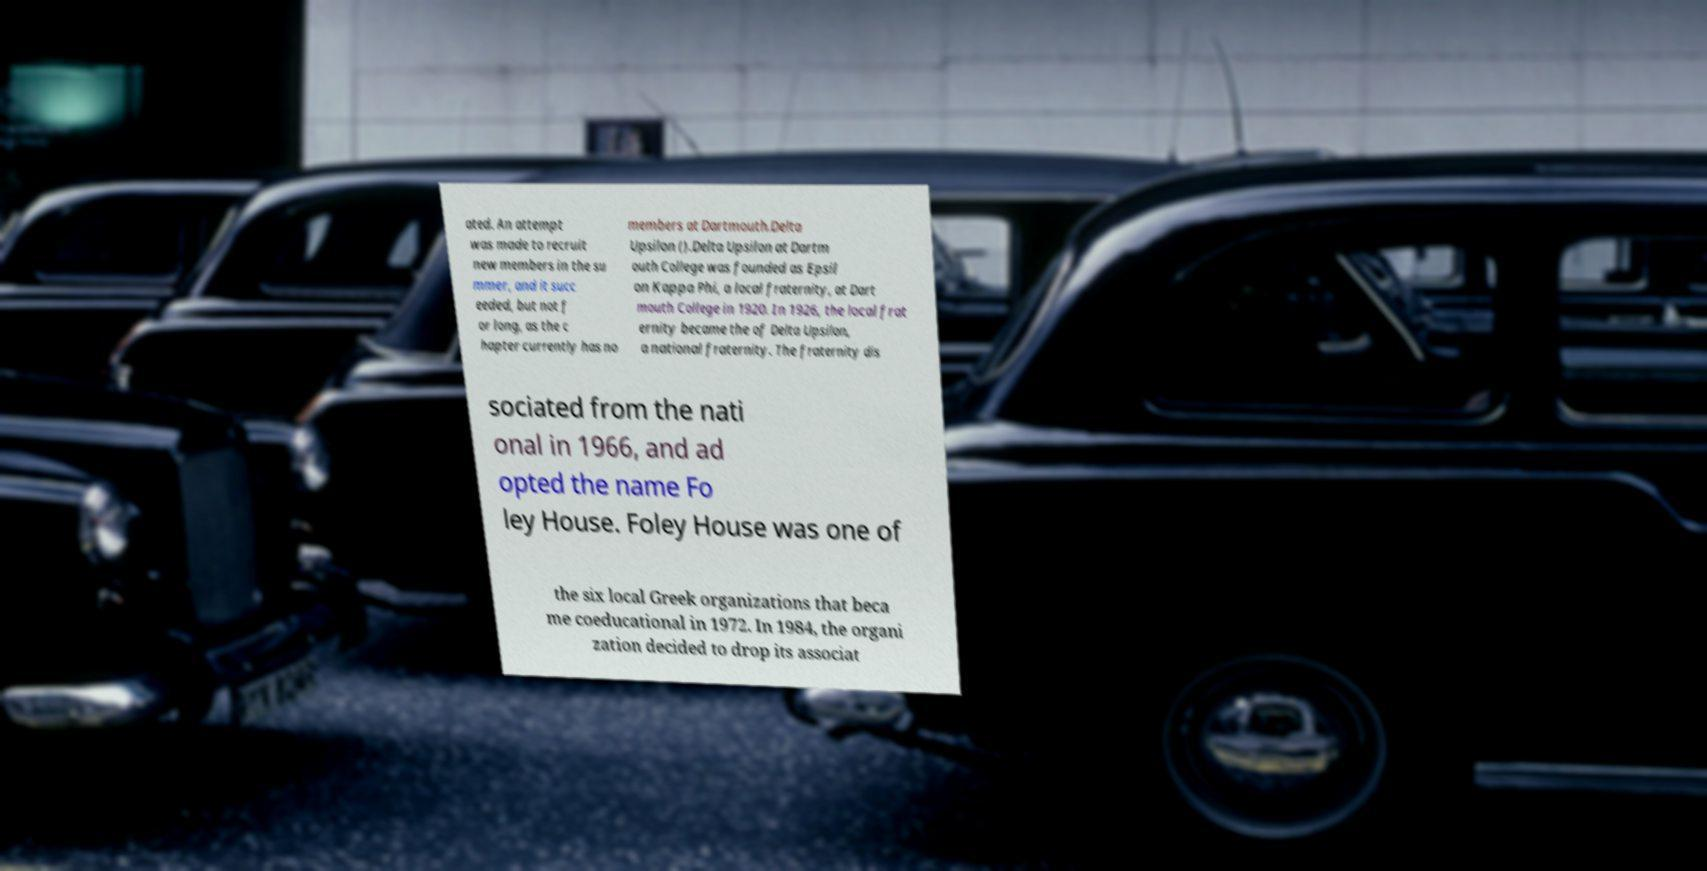Could you assist in decoding the text presented in this image and type it out clearly? ated. An attempt was made to recruit new members in the su mmer, and it succ eeded, but not f or long, as the c hapter currently has no members at Dartmouth.Delta Upsilon ().Delta Upsilon at Dartm outh College was founded as Epsil on Kappa Phi, a local fraternity, at Dart mouth College in 1920. In 1926, the local frat ernity became the of Delta Upsilon, a national fraternity. The fraternity dis sociated from the nati onal in 1966, and ad opted the name Fo ley House. Foley House was one of the six local Greek organizations that beca me coeducational in 1972. In 1984, the organi zation decided to drop its associat 